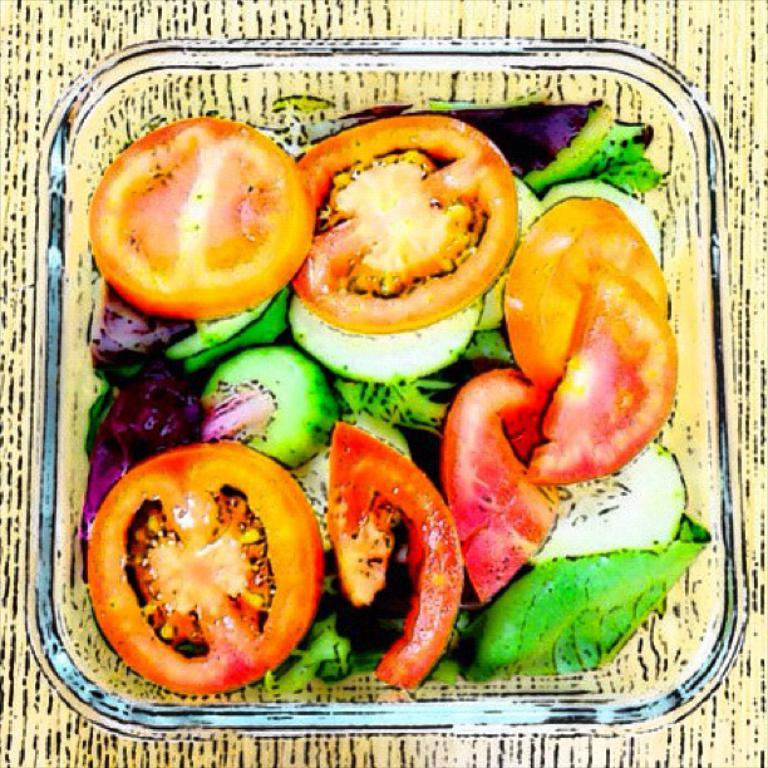What is located on the table in the image? There is a bowl on the table in the image. Can you describe the bowl in the image? The bowl is the main subject in the image, but no further details about its contents or appearance are provided. What type of bait is being used to catch fish in the image? There is no reference to fishing or bait in the image; it only features a bowl on a table. 